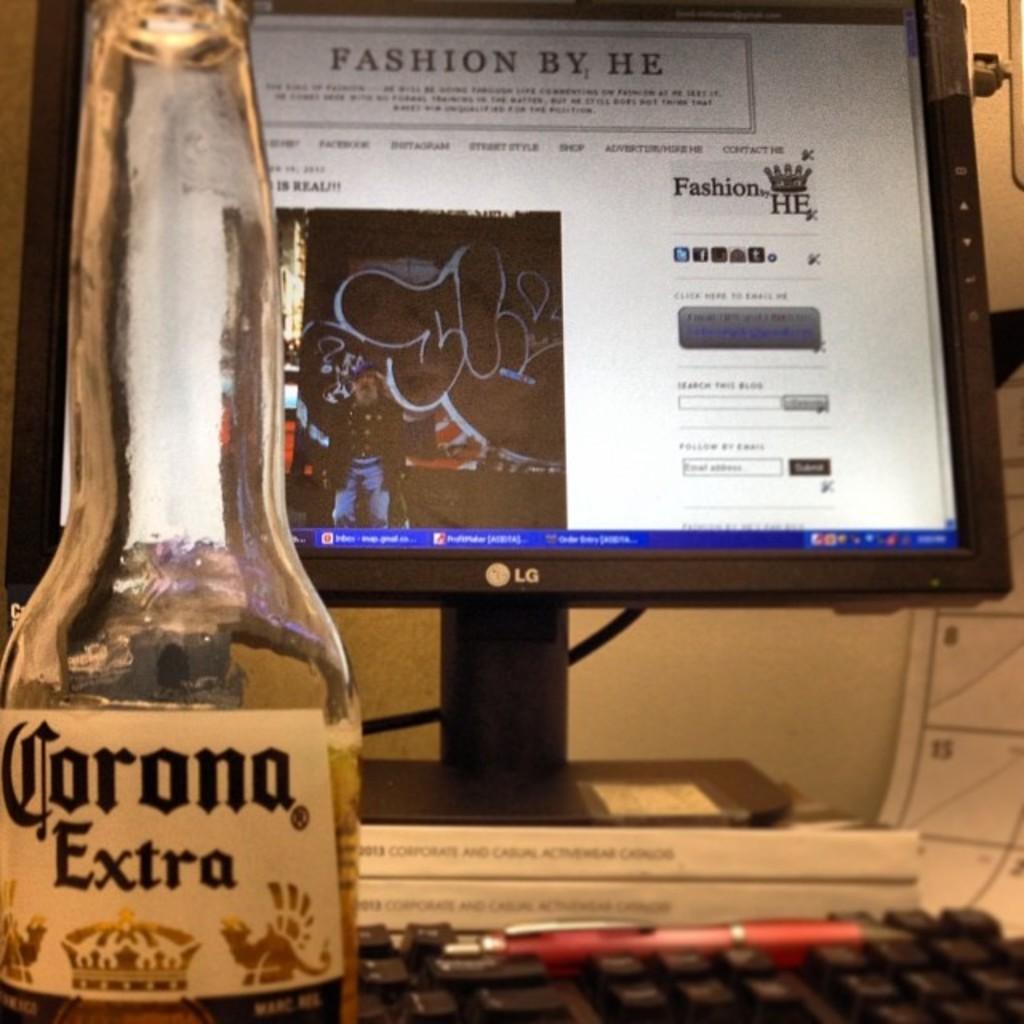What brand of monitor is this?
Your response must be concise. Lg. 